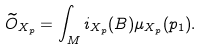<formula> <loc_0><loc_0><loc_500><loc_500>\widetilde { O } _ { { X } _ { p } } = \int _ { M } i _ { { X } _ { p } } ( B ) \mu _ { { X } _ { p } } ( p _ { 1 } ) .</formula> 